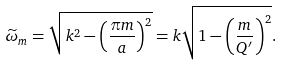<formula> <loc_0><loc_0><loc_500><loc_500>\widetilde { \omega } _ { m } = \sqrt { k ^ { 2 } - \left ( \frac { \pi m } { a } \right ) ^ { 2 } } = k \sqrt { 1 - \left ( \frac { m } { Q ^ { \prime } } \right ) ^ { 2 } } .</formula> 